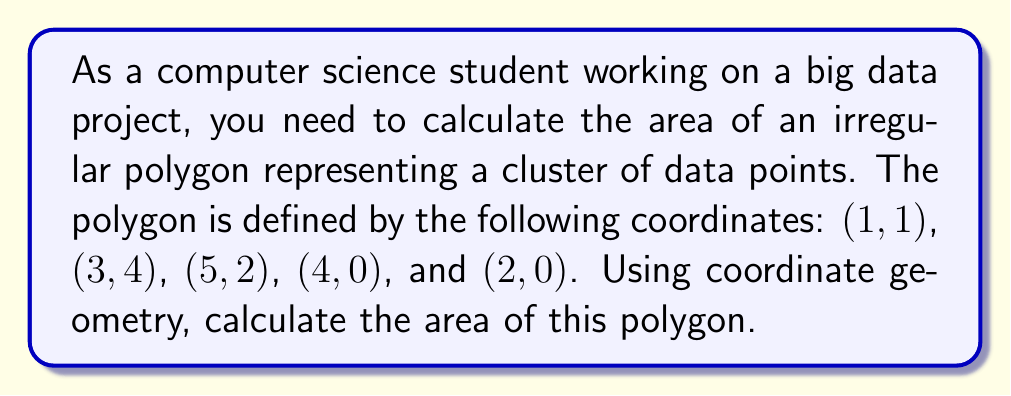Show me your answer to this math problem. To calculate the area of a polygon using coordinate geometry, we can use the Shoelace formula (also known as the surveyor's formula). The steps are as follows:

1. List the coordinates in order (clockwise or counterclockwise):
   $(x_1, y_1) = (1, 1)$
   $(x_2, y_2) = (3, 4)$
   $(x_3, y_3) = (5, 2)$
   $(x_4, y_4) = (4, 0)$
   $(x_5, y_5) = (2, 0)$

2. Apply the Shoelace formula:
   $$A = \frac{1}{2}|(x_1y_2 + x_2y_3 + x_3y_4 + x_4y_5 + x_5y_1) - (y_1x_2 + y_2x_3 + y_3x_4 + y_4x_5 + y_5x_1)|$$

3. Substitute the values:
   $$A = \frac{1}{2}|(1 \cdot 4 + 3 \cdot 2 + 5 \cdot 0 + 4 \cdot 0 + 2 \cdot 1) - (1 \cdot 3 + 4 \cdot 5 + 2 \cdot 4 + 0 \cdot 2 + 0 \cdot 1)|$$

4. Calculate the sums:
   $$A = \frac{1}{2}|(4 + 6 + 0 + 0 + 2) - (3 + 20 + 8 + 0 + 0)|$$
   $$A = \frac{1}{2}|12 - 31|$$

5. Simplify:
   $$A = \frac{1}{2} \cdot 19 = 9.5$$

Therefore, the area of the polygon is 9.5 square units.
Answer: 9.5 square units 